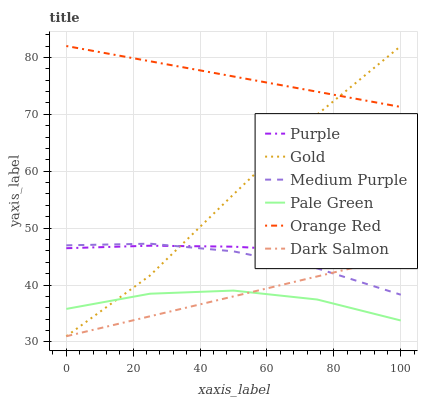Does Pale Green have the minimum area under the curve?
Answer yes or no. Yes. Does Orange Red have the maximum area under the curve?
Answer yes or no. Yes. Does Purple have the minimum area under the curve?
Answer yes or no. No. Does Purple have the maximum area under the curve?
Answer yes or no. No. Is Dark Salmon the smoothest?
Answer yes or no. Yes. Is Pale Green the roughest?
Answer yes or no. Yes. Is Purple the smoothest?
Answer yes or no. No. Is Purple the roughest?
Answer yes or no. No. Does Gold have the lowest value?
Answer yes or no. Yes. Does Purple have the lowest value?
Answer yes or no. No. Does Orange Red have the highest value?
Answer yes or no. Yes. Does Purple have the highest value?
Answer yes or no. No. Is Pale Green less than Medium Purple?
Answer yes or no. Yes. Is Orange Red greater than Medium Purple?
Answer yes or no. Yes. Does Dark Salmon intersect Pale Green?
Answer yes or no. Yes. Is Dark Salmon less than Pale Green?
Answer yes or no. No. Is Dark Salmon greater than Pale Green?
Answer yes or no. No. Does Pale Green intersect Medium Purple?
Answer yes or no. No. 